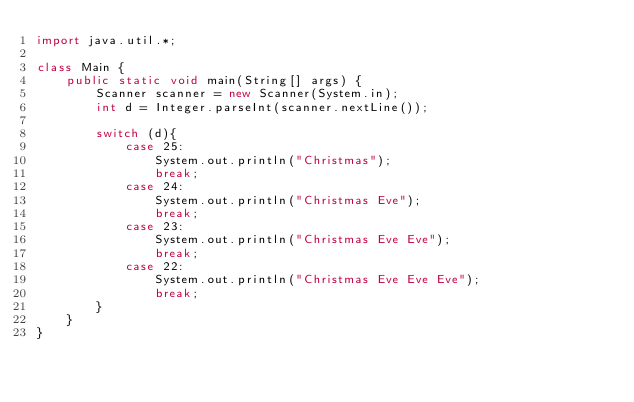<code> <loc_0><loc_0><loc_500><loc_500><_Java_>import java.util.*;

class Main {
    public static void main(String[] args) {
        Scanner scanner = new Scanner(System.in);
        int d = Integer.parseInt(scanner.nextLine());

        switch (d){
            case 25:
                System.out.println("Christmas");
                break;
            case 24:
                System.out.println("Christmas Eve");
                break;
            case 23:
                System.out.println("Christmas Eve Eve");
                break;
            case 22:
                System.out.println("Christmas Eve Eve Eve");
                break;
        }
    }
}
</code> 